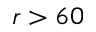Convert formula to latex. <formula><loc_0><loc_0><loc_500><loc_500>r > 6 0</formula> 